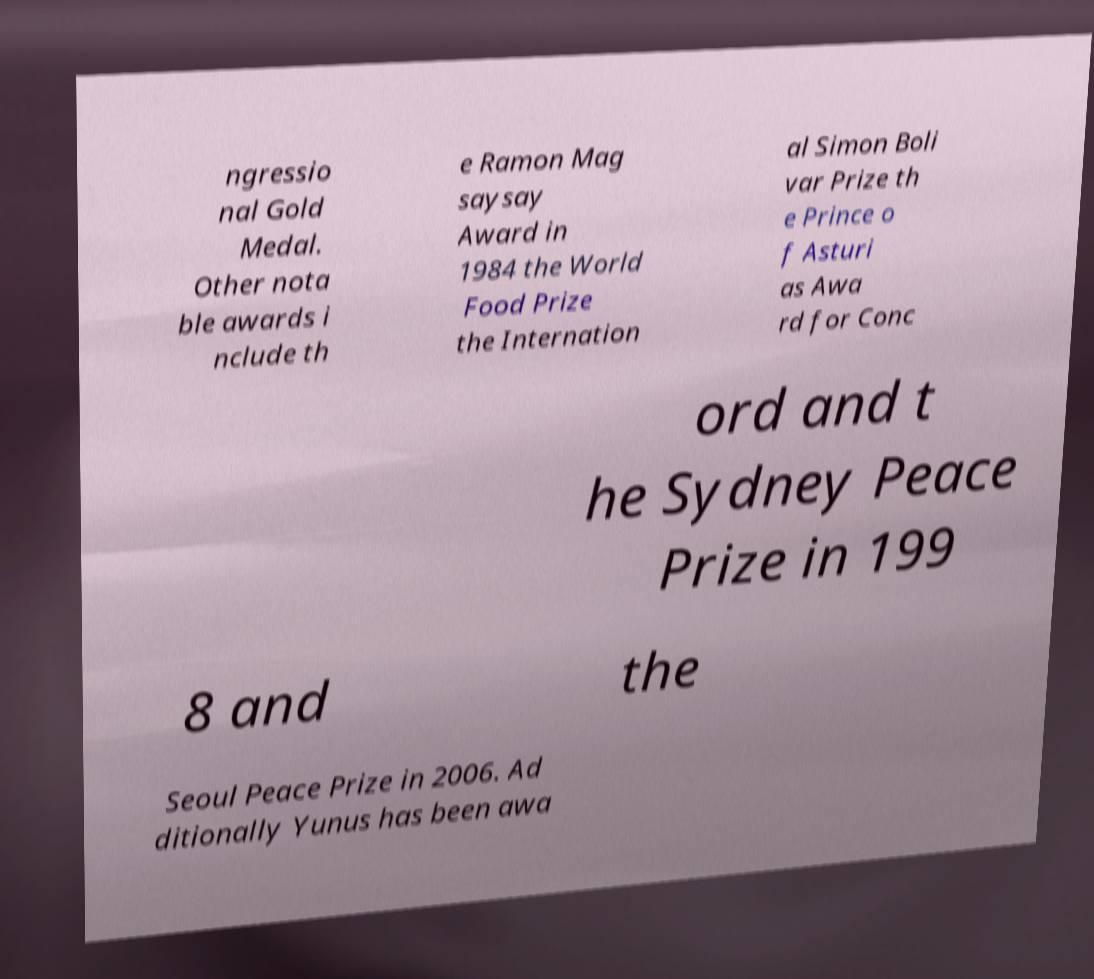Please read and relay the text visible in this image. What does it say? ngressio nal Gold Medal. Other nota ble awards i nclude th e Ramon Mag saysay Award in 1984 the World Food Prize the Internation al Simon Boli var Prize th e Prince o f Asturi as Awa rd for Conc ord and t he Sydney Peace Prize in 199 8 and the Seoul Peace Prize in 2006. Ad ditionally Yunus has been awa 